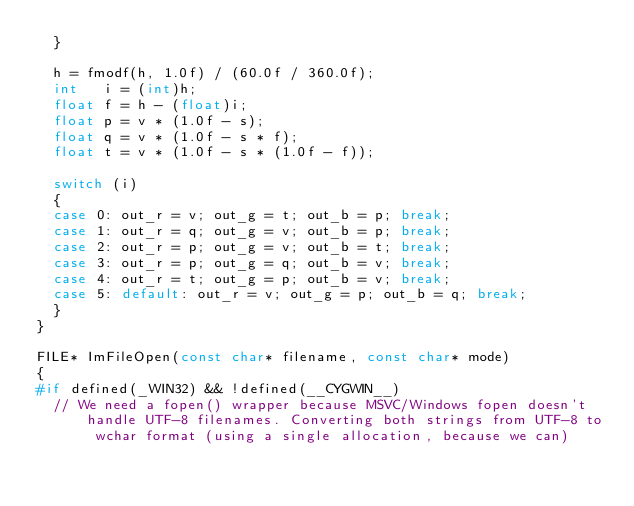<code> <loc_0><loc_0><loc_500><loc_500><_C++_>	}

	h = fmodf(h, 1.0f) / (60.0f / 360.0f);
	int   i = (int)h;
	float f = h - (float)i;
	float p = v * (1.0f - s);
	float q = v * (1.0f - s * f);
	float t = v * (1.0f - s * (1.0f - f));

	switch (i)
	{
	case 0: out_r = v; out_g = t; out_b = p; break;
	case 1: out_r = q; out_g = v; out_b = p; break;
	case 2: out_r = p; out_g = v; out_b = t; break;
	case 3: out_r = p; out_g = q; out_b = v; break;
	case 4: out_r = t; out_g = p; out_b = v; break;
	case 5: default: out_r = v; out_g = p; out_b = q; break;
	}
}

FILE* ImFileOpen(const char* filename, const char* mode)
{
#if defined(_WIN32) && !defined(__CYGWIN__)
	// We need a fopen() wrapper because MSVC/Windows fopen doesn't handle UTF-8 filenames. Converting both strings from UTF-8 to wchar format (using a single allocation, because we can)</code> 